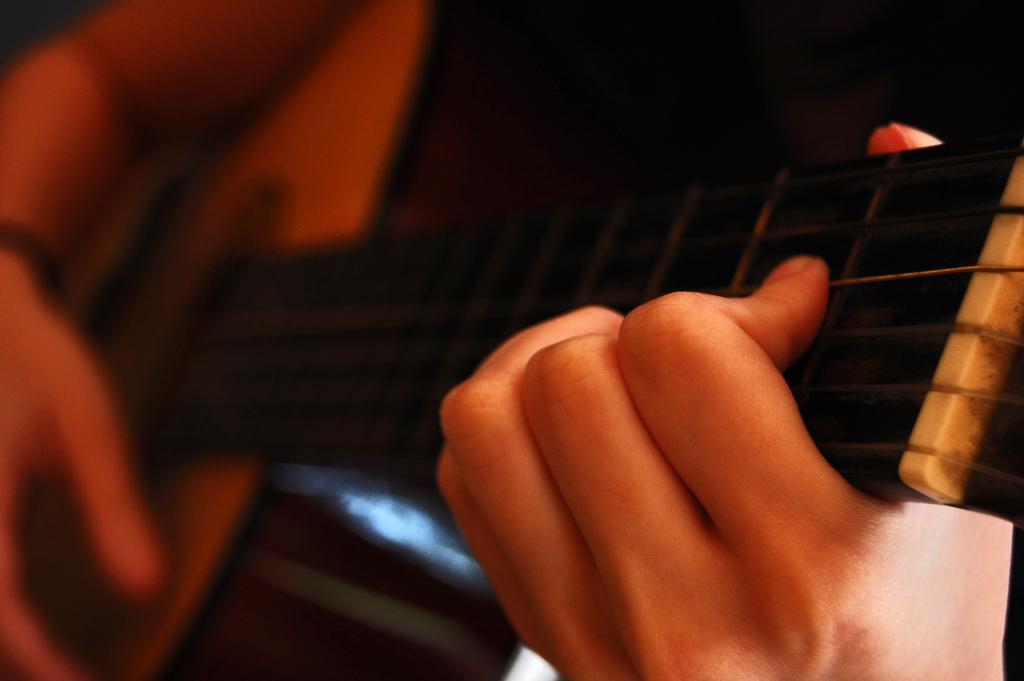What is being held by the hands in the image? The hands are holding a guitar. Can you describe the hands in the image? The hands are human hands. How would you describe the quality of the image? The image is slightly blurred. What type of key is being used to unlock the poison in the image? There is no key or poison present in the image; it features human hands holding a guitar. 